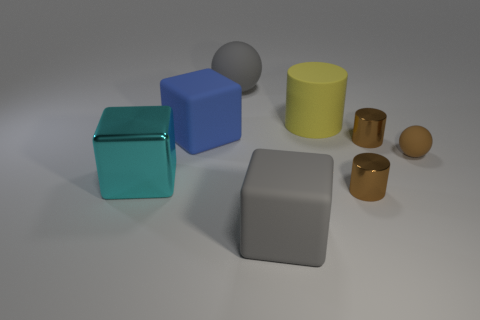Add 1 brown metallic spheres. How many objects exist? 9 Subtract all balls. How many objects are left? 6 Subtract all spheres. Subtract all brown shiny things. How many objects are left? 4 Add 2 big rubber cubes. How many big rubber cubes are left? 4 Add 7 tiny metallic cylinders. How many tiny metallic cylinders exist? 9 Subtract 1 cyan blocks. How many objects are left? 7 